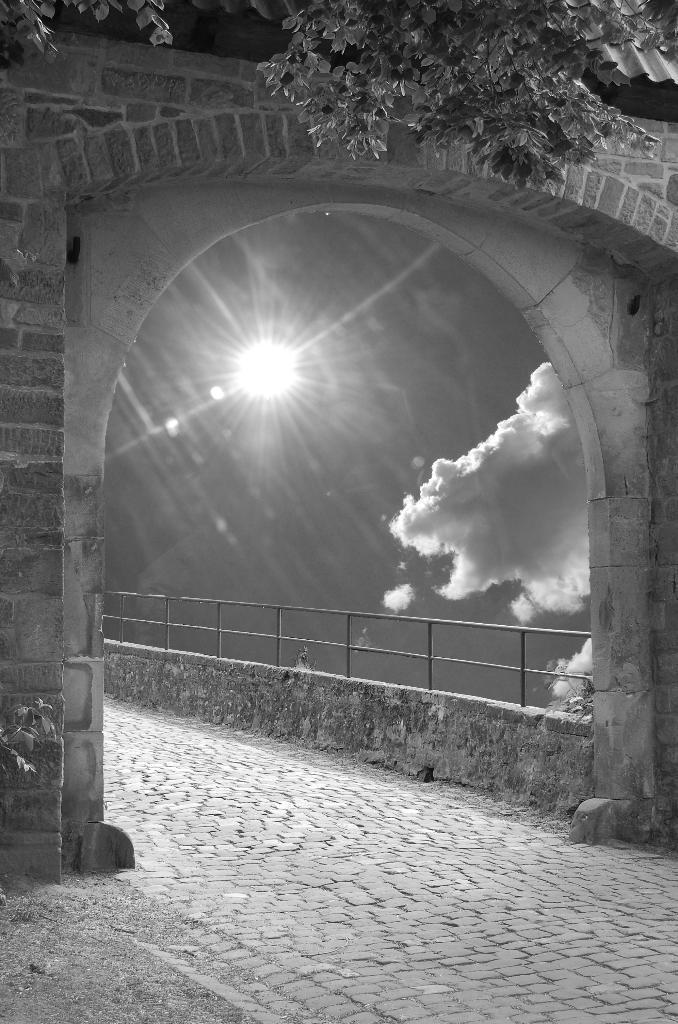Please provide a concise description of this image. This is a black and white image. In this image we can see an arch, walking path, railings and sky with clouds. 